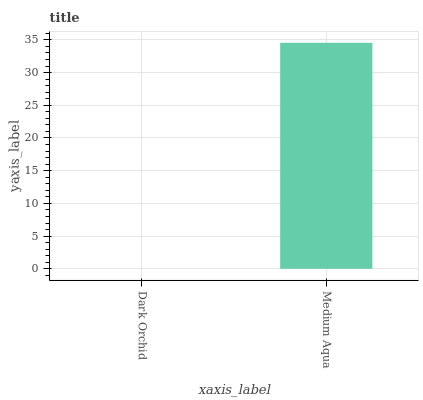Is Dark Orchid the minimum?
Answer yes or no. Yes. Is Medium Aqua the maximum?
Answer yes or no. Yes. Is Medium Aqua the minimum?
Answer yes or no. No. Is Medium Aqua greater than Dark Orchid?
Answer yes or no. Yes. Is Dark Orchid less than Medium Aqua?
Answer yes or no. Yes. Is Dark Orchid greater than Medium Aqua?
Answer yes or no. No. Is Medium Aqua less than Dark Orchid?
Answer yes or no. No. Is Medium Aqua the high median?
Answer yes or no. Yes. Is Dark Orchid the low median?
Answer yes or no. Yes. Is Dark Orchid the high median?
Answer yes or no. No. Is Medium Aqua the low median?
Answer yes or no. No. 